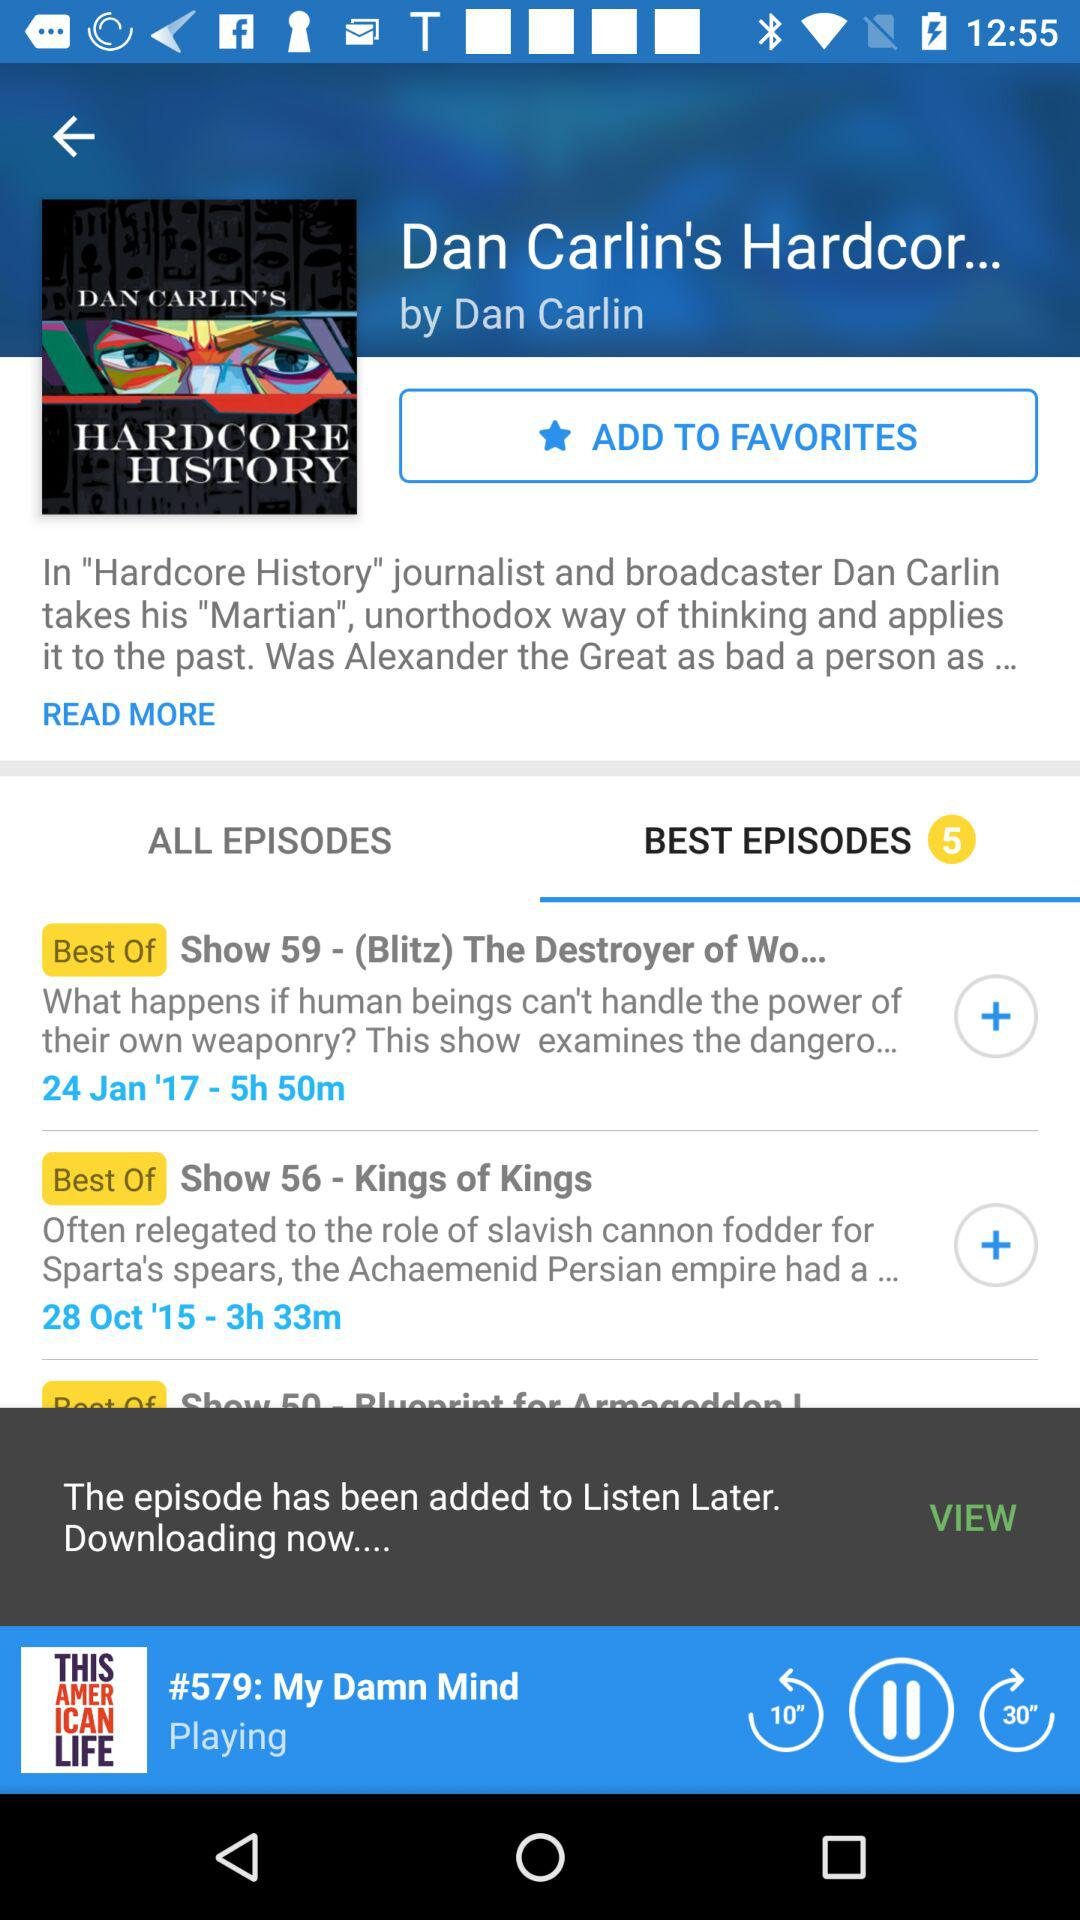Which audio is playing? The playing audio is "#579: My Damn Mind". 